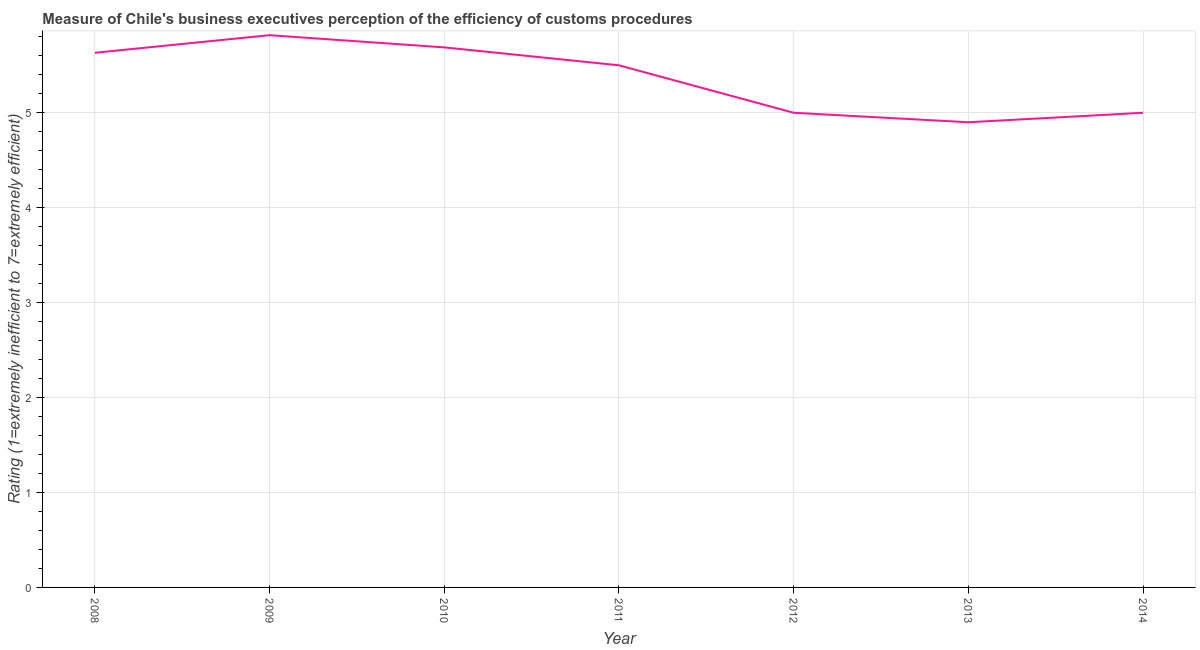Across all years, what is the maximum rating measuring burden of customs procedure?
Offer a terse response. 5.82. Across all years, what is the minimum rating measuring burden of customs procedure?
Offer a very short reply. 4.9. What is the sum of the rating measuring burden of customs procedure?
Keep it short and to the point. 37.54. What is the difference between the rating measuring burden of customs procedure in 2010 and 2011?
Make the answer very short. 0.19. What is the average rating measuring burden of customs procedure per year?
Your response must be concise. 5.36. What is the median rating measuring burden of customs procedure?
Give a very brief answer. 5.5. In how many years, is the rating measuring burden of customs procedure greater than 2.6 ?
Your answer should be compact. 7. Do a majority of the years between 2013 and 2012 (inclusive) have rating measuring burden of customs procedure greater than 4.8 ?
Your answer should be compact. No. What is the ratio of the rating measuring burden of customs procedure in 2011 to that in 2014?
Your answer should be compact. 1.1. Is the rating measuring burden of customs procedure in 2012 less than that in 2013?
Your response must be concise. No. What is the difference between the highest and the second highest rating measuring burden of customs procedure?
Keep it short and to the point. 0.13. What is the difference between the highest and the lowest rating measuring burden of customs procedure?
Make the answer very short. 0.92. Does the rating measuring burden of customs procedure monotonically increase over the years?
Offer a terse response. No. How many lines are there?
Offer a very short reply. 1. How many years are there in the graph?
Provide a succinct answer. 7. What is the title of the graph?
Offer a very short reply. Measure of Chile's business executives perception of the efficiency of customs procedures. What is the label or title of the Y-axis?
Ensure brevity in your answer.  Rating (1=extremely inefficient to 7=extremely efficient). What is the Rating (1=extremely inefficient to 7=extremely efficient) in 2008?
Your answer should be very brief. 5.63. What is the Rating (1=extremely inefficient to 7=extremely efficient) in 2009?
Offer a very short reply. 5.82. What is the Rating (1=extremely inefficient to 7=extremely efficient) of 2010?
Ensure brevity in your answer.  5.69. What is the Rating (1=extremely inefficient to 7=extremely efficient) in 2012?
Offer a terse response. 5. What is the Rating (1=extremely inefficient to 7=extremely efficient) of 2014?
Give a very brief answer. 5. What is the difference between the Rating (1=extremely inefficient to 7=extremely efficient) in 2008 and 2009?
Your response must be concise. -0.19. What is the difference between the Rating (1=extremely inefficient to 7=extremely efficient) in 2008 and 2010?
Your answer should be very brief. -0.06. What is the difference between the Rating (1=extremely inefficient to 7=extremely efficient) in 2008 and 2011?
Your response must be concise. 0.13. What is the difference between the Rating (1=extremely inefficient to 7=extremely efficient) in 2008 and 2012?
Give a very brief answer. 0.63. What is the difference between the Rating (1=extremely inefficient to 7=extremely efficient) in 2008 and 2013?
Your response must be concise. 0.73. What is the difference between the Rating (1=extremely inefficient to 7=extremely efficient) in 2008 and 2014?
Ensure brevity in your answer.  0.63. What is the difference between the Rating (1=extremely inefficient to 7=extremely efficient) in 2009 and 2010?
Provide a succinct answer. 0.13. What is the difference between the Rating (1=extremely inefficient to 7=extremely efficient) in 2009 and 2011?
Give a very brief answer. 0.32. What is the difference between the Rating (1=extremely inefficient to 7=extremely efficient) in 2009 and 2012?
Provide a short and direct response. 0.82. What is the difference between the Rating (1=extremely inefficient to 7=extremely efficient) in 2009 and 2013?
Ensure brevity in your answer.  0.92. What is the difference between the Rating (1=extremely inefficient to 7=extremely efficient) in 2009 and 2014?
Offer a very short reply. 0.82. What is the difference between the Rating (1=extremely inefficient to 7=extremely efficient) in 2010 and 2011?
Your answer should be very brief. 0.19. What is the difference between the Rating (1=extremely inefficient to 7=extremely efficient) in 2010 and 2012?
Give a very brief answer. 0.69. What is the difference between the Rating (1=extremely inefficient to 7=extremely efficient) in 2010 and 2013?
Offer a very short reply. 0.79. What is the difference between the Rating (1=extremely inefficient to 7=extremely efficient) in 2010 and 2014?
Keep it short and to the point. 0.69. What is the difference between the Rating (1=extremely inefficient to 7=extremely efficient) in 2011 and 2013?
Make the answer very short. 0.6. What is the ratio of the Rating (1=extremely inefficient to 7=extremely efficient) in 2008 to that in 2009?
Keep it short and to the point. 0.97. What is the ratio of the Rating (1=extremely inefficient to 7=extremely efficient) in 2008 to that in 2010?
Your answer should be very brief. 0.99. What is the ratio of the Rating (1=extremely inefficient to 7=extremely efficient) in 2008 to that in 2011?
Provide a succinct answer. 1.02. What is the ratio of the Rating (1=extremely inefficient to 7=extremely efficient) in 2008 to that in 2012?
Give a very brief answer. 1.13. What is the ratio of the Rating (1=extremely inefficient to 7=extremely efficient) in 2008 to that in 2013?
Provide a succinct answer. 1.15. What is the ratio of the Rating (1=extremely inefficient to 7=extremely efficient) in 2008 to that in 2014?
Your response must be concise. 1.13. What is the ratio of the Rating (1=extremely inefficient to 7=extremely efficient) in 2009 to that in 2011?
Provide a succinct answer. 1.06. What is the ratio of the Rating (1=extremely inefficient to 7=extremely efficient) in 2009 to that in 2012?
Make the answer very short. 1.16. What is the ratio of the Rating (1=extremely inefficient to 7=extremely efficient) in 2009 to that in 2013?
Your response must be concise. 1.19. What is the ratio of the Rating (1=extremely inefficient to 7=extremely efficient) in 2009 to that in 2014?
Keep it short and to the point. 1.16. What is the ratio of the Rating (1=extremely inefficient to 7=extremely efficient) in 2010 to that in 2011?
Your response must be concise. 1.03. What is the ratio of the Rating (1=extremely inefficient to 7=extremely efficient) in 2010 to that in 2012?
Your answer should be compact. 1.14. What is the ratio of the Rating (1=extremely inefficient to 7=extremely efficient) in 2010 to that in 2013?
Provide a succinct answer. 1.16. What is the ratio of the Rating (1=extremely inefficient to 7=extremely efficient) in 2010 to that in 2014?
Your answer should be compact. 1.14. What is the ratio of the Rating (1=extremely inefficient to 7=extremely efficient) in 2011 to that in 2013?
Your answer should be very brief. 1.12. What is the ratio of the Rating (1=extremely inefficient to 7=extremely efficient) in 2012 to that in 2013?
Give a very brief answer. 1.02. What is the ratio of the Rating (1=extremely inefficient to 7=extremely efficient) in 2012 to that in 2014?
Offer a terse response. 1. What is the ratio of the Rating (1=extremely inefficient to 7=extremely efficient) in 2013 to that in 2014?
Make the answer very short. 0.98. 